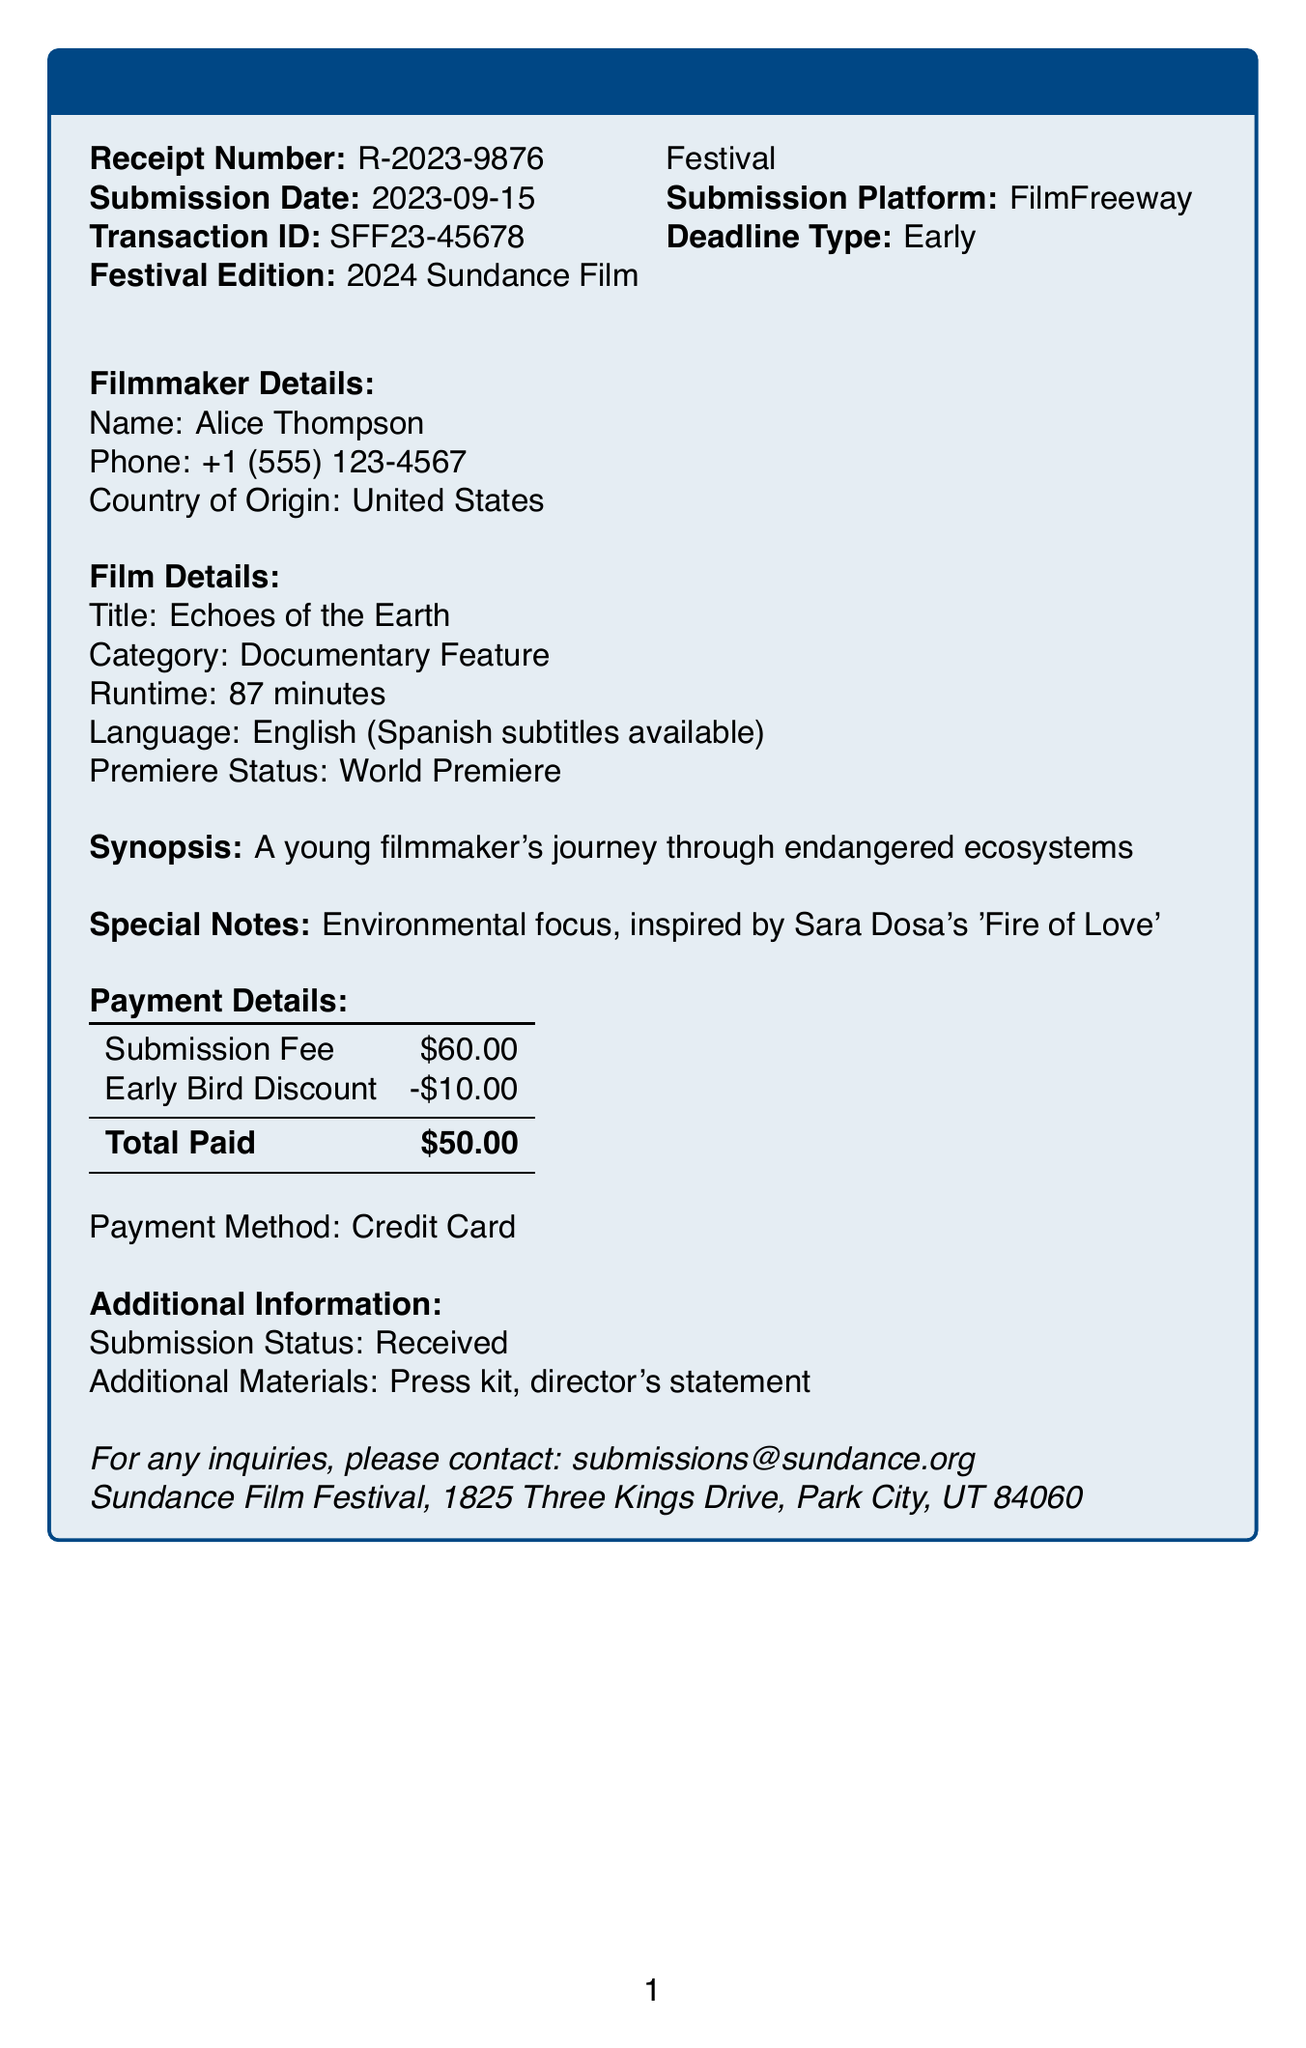What is the film title? The film title is specifically mentioned in the document under "Film Details."
Answer: Echoes of the Earth Who is the filmmaker? The document states the name of the filmmaker under "Filmmaker Details."
Answer: Alice Thompson What is the category of the film? The category is listed in the "Film Details" section of the receipt.
Answer: Documentary Feature What is the subtotal before the discount? The subtotal, or submission fee, is listed directly in the payment details.
Answer: $60.00 What is the total amount paid? The total amount paid is provided in the payment details section of the receipt.
Answer: $50.00 What is the premiere status of the film? The premiere status is indicated in the "Film Details" section.
Answer: World Premiere What is the submission date? The submission date is listed prominently in the receipt.
Answer: 2023-09-15 What payment method was used? The method of payment is clearly mentioned in the "Payment Details" section of the document.
Answer: Credit Card What is the contact email for inquiries? The contact email for the festival is provided at the end of the document.
Answer: submissions@sundance.org 